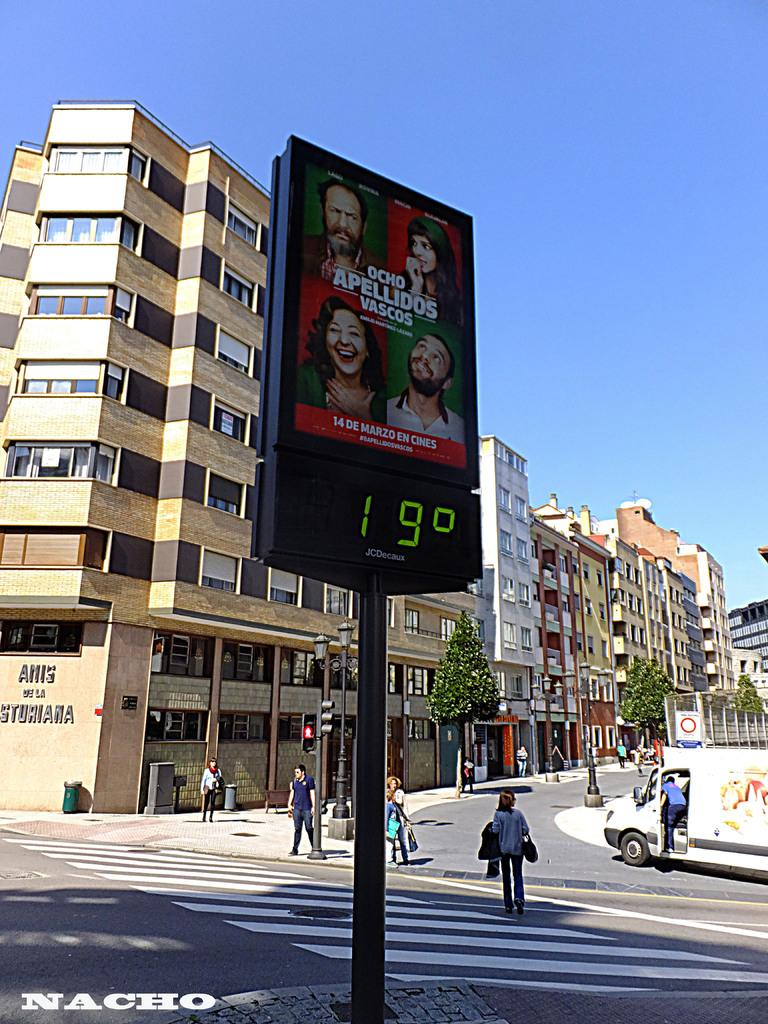<image>
Write a terse but informative summary of the picture. a street sign shows the number 19 while people walk by on a crosswalk 